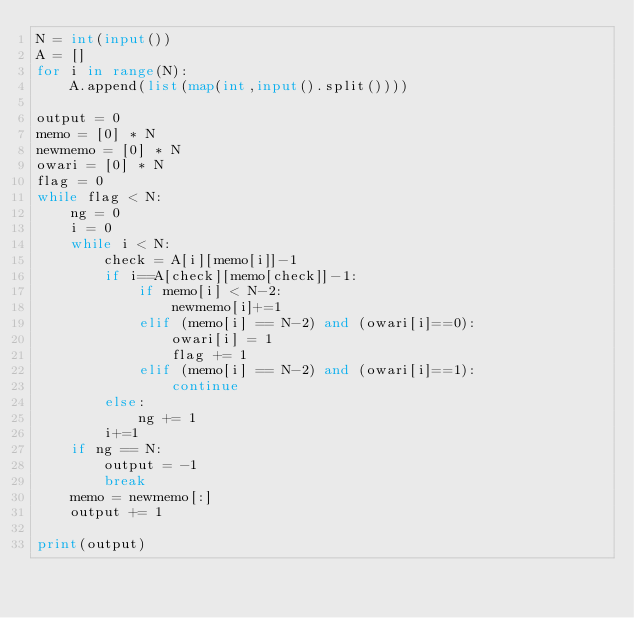<code> <loc_0><loc_0><loc_500><loc_500><_Python_>N = int(input())
A = []
for i in range(N):
    A.append(list(map(int,input().split())))

output = 0
memo = [0] * N
newmemo = [0] * N
owari = [0] * N
flag = 0
while flag < N:
    ng = 0
    i = 0
    while i < N:
        check = A[i][memo[i]]-1
        if i==A[check][memo[check]]-1:
            if memo[i] < N-2:
                newmemo[i]+=1
            elif (memo[i] == N-2) and (owari[i]==0):
                owari[i] = 1
                flag += 1
            elif (memo[i] == N-2) and (owari[i]==1):
                continue
        else:
            ng += 1
        i+=1
    if ng == N:
        output = -1
        break
    memo = newmemo[:]
    output += 1

print(output)</code> 